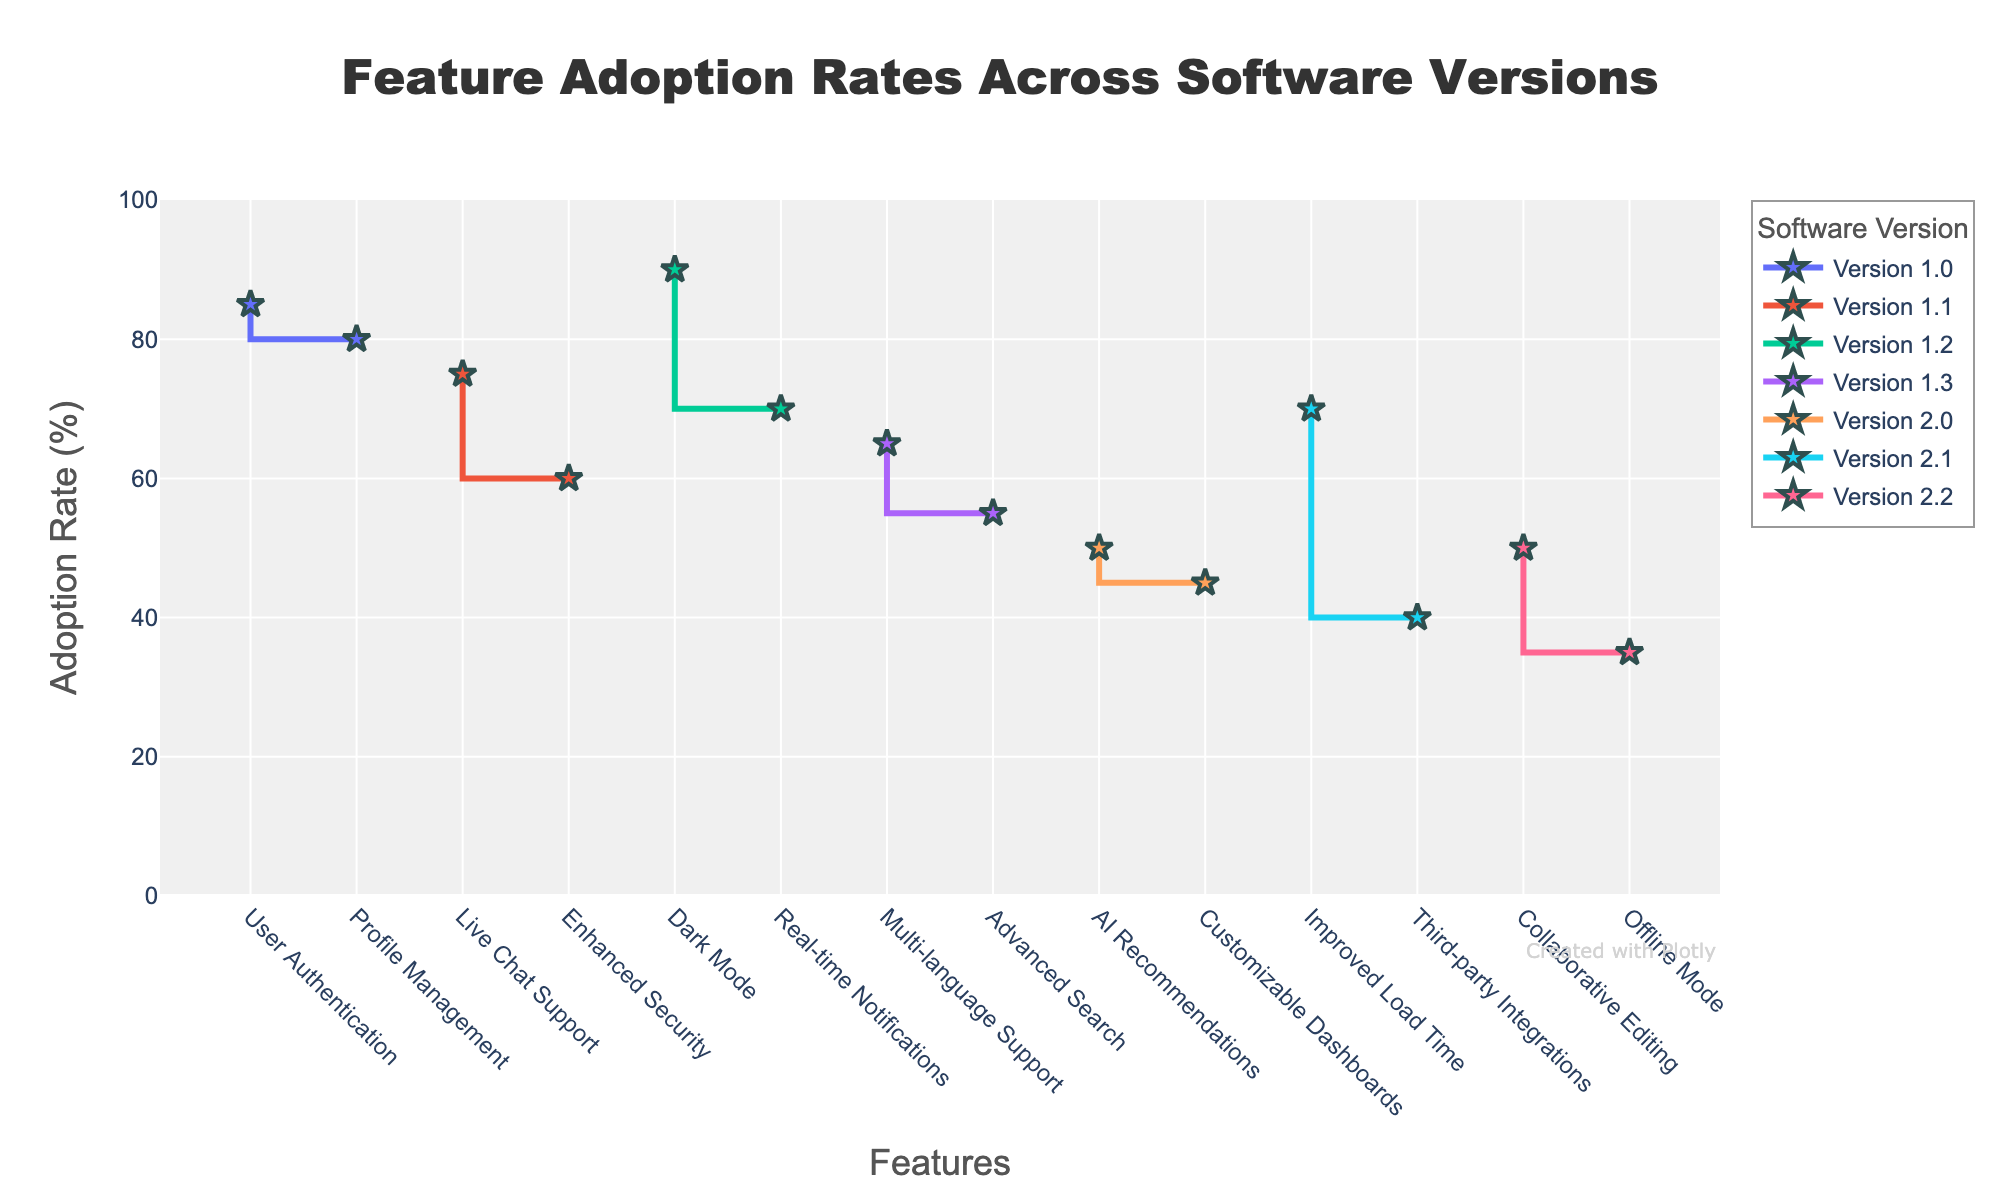What is the highest adoption rate for version 1.2? For version 1.2, look for the highest y-value (adoption rate) among features: Dark Mode (90%) and Real-time Notifications (70%). The highest adoption rate is 90%.
Answer: 90% Which feature has the lowest adoption rate in version 2.1? For version 2.1, compare the y-values (adoption rates) of features: Third-party Integrations (40%) and Improved Load Time (70%). The lowest adoption rate is 40%.
Answer: Third-party Integrations What's the average adoption rate for the features in version 2.0? The adoption rates for version 2.0 are AI Recommendations (50%) and Customizable Dashboards (45%). The average is (50 + 45) / 2 = 47.5.
Answer: 47.5% Which version has the most features with an adoption rate above 60%? Compare the number of features above 60% in all versions: 
- 1.0: 2 features (User Authentication, Profile Management)
- 1.1: 1 feature (Live Chat Support)
- 1.2: 1 feature (Dark Mode)
- 1.3: 1 feature (Multi-language Support)
- 2.0: 0 features
- 2.1: 1 feature (Improved Load Time)
- 2.2: 0 features
Version 1.0 has the most features above 60%.
Answer: Version 1.0 What's the difference in adoption rates between the highest feature in version 1.3 and the lowest feature in version 2.2? Highest in 1.3 is Multi-language Support (65%). Lowest in 2.2 is Offline Mode (35%). Difference = 65 - 35 = 30.
Answer: 30 Which feature in version 1.1 has a lower adoption rate? For version 1.1, compare Live Chat Support (75%) and Enhanced Security (60%). The lower adoption rate is 60%.
Answer: Enhanced Security How many features in total are displayed in the figure? Count the total number of unique features in all versions: User Authentication, Profile Management, Live Chat Support, Enhanced Security, Dark Mode, Real-time Notifications, Multi-language Support, Advanced Search, AI Recommendations, Customizable Dashboards, Third-party Integrations, Improved Load Time, Offline Mode, Collaborative Editing. Total is 14.
Answer: 14 Which version introduces features with the highest average adoption rate? Calculate the average adoption rate for each version's features and compare:
- 1.0: (85 + 80) / 2 = 82.5
- 1.1: (75 + 60) / 2 = 67.5
- 1.2: (90 + 70) / 2 = 80
- 1.3: (65 + 55) / 2 = 60
- 2.0: (50 + 45) / 2 = 47.5
- 2.1: (40 + 70) / 2 = 55
- 2.2: (35 + 50) / 2 = 42.5
The highest average adoption rate is 82.5 in version 1.0.
Answer: Version 1.0 